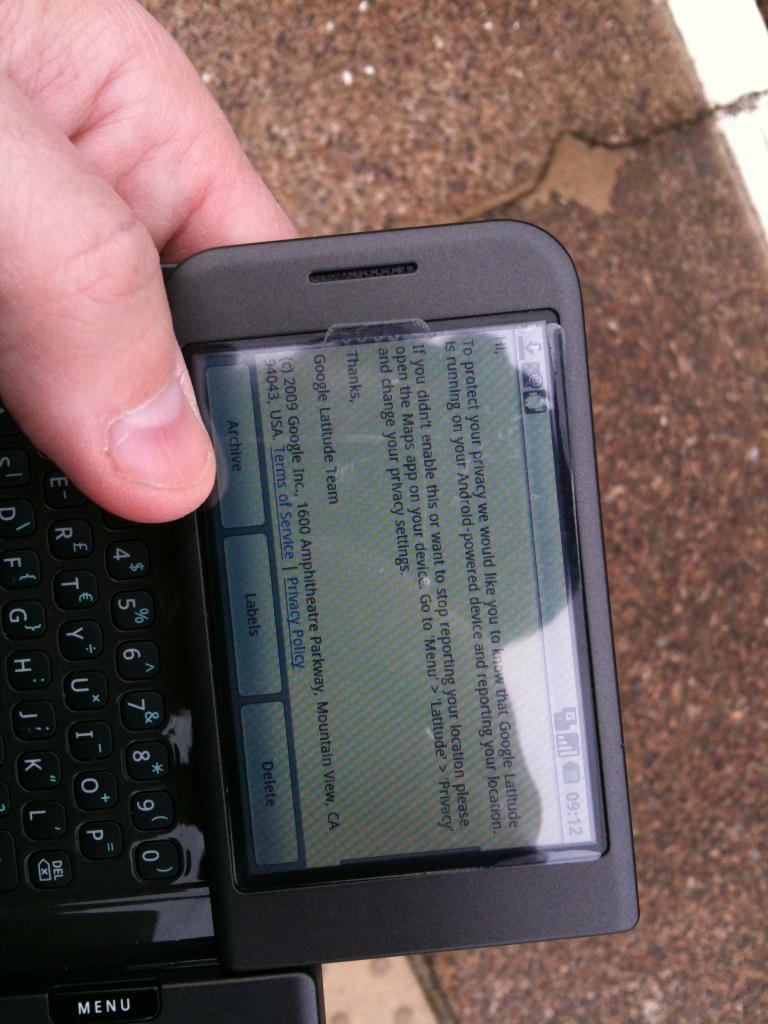<image>
Render a clear and concise summary of the photo. a black slider phone that says 09:12 as the time 